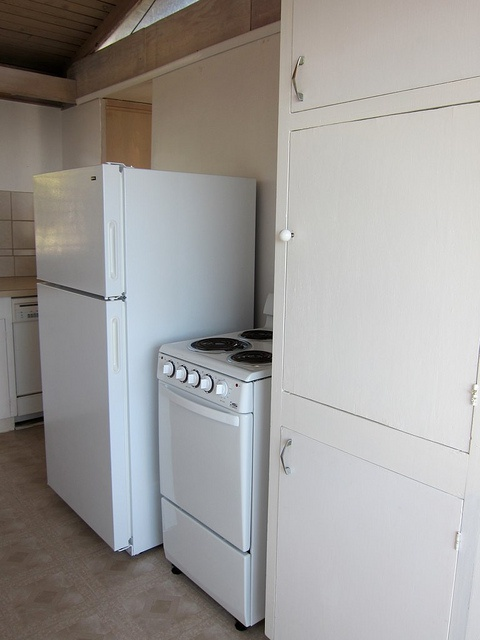Describe the objects in this image and their specific colors. I can see refrigerator in black, darkgray, gray, and lightgray tones and oven in black, darkgray, gray, and lightgray tones in this image. 